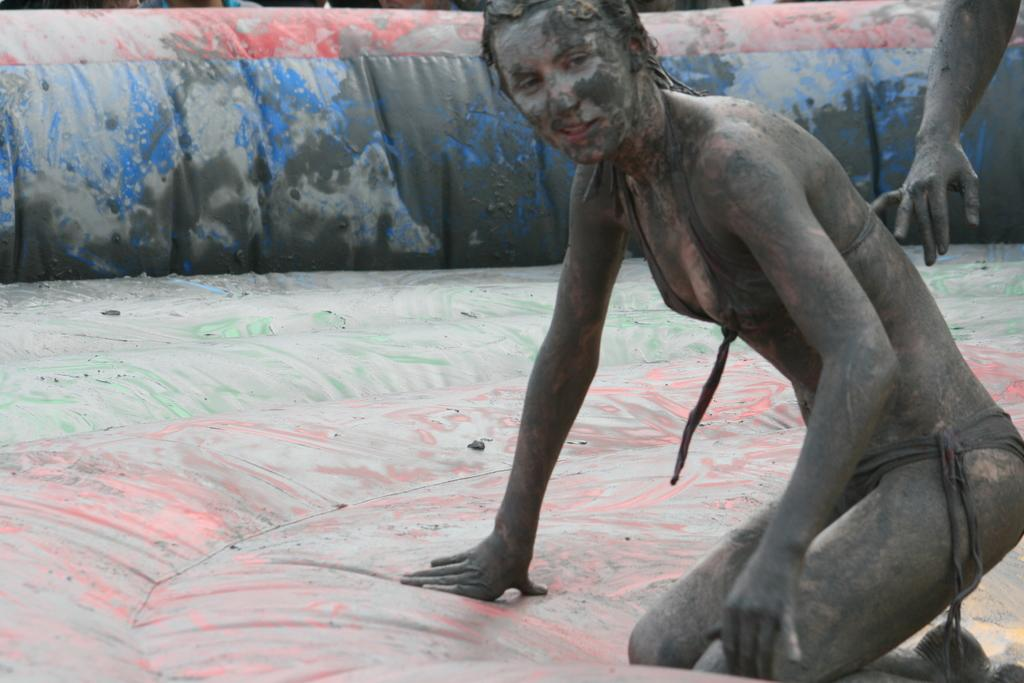Who is the main subject in the image? There is a woman in the center of the image. What is the woman doing in the image? The woman is smiling. Can you describe any other person or body part visible in the image? There is a visible hand of a person on the right side of the image. What historical event is being commemorated by the woman in the image? There is no indication of a historical event being commemorated in the image. 